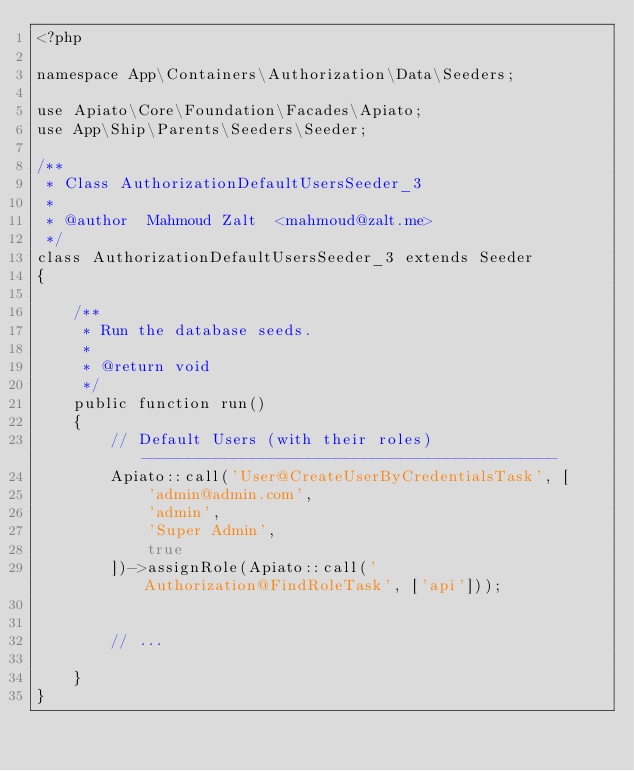Convert code to text. <code><loc_0><loc_0><loc_500><loc_500><_PHP_><?php

namespace App\Containers\Authorization\Data\Seeders;

use Apiato\Core\Foundation\Facades\Apiato;
use App\Ship\Parents\Seeders\Seeder;

/**
 * Class AuthorizationDefaultUsersSeeder_3
 *
 * @author  Mahmoud Zalt  <mahmoud@zalt.me>
 */
class AuthorizationDefaultUsersSeeder_3 extends Seeder
{

    /**
     * Run the database seeds.
     *
     * @return void
     */
    public function run()
    {
        // Default Users (with their roles) ---------------------------------------------
        Apiato::call('User@CreateUserByCredentialsTask', [
            'admin@admin.com',
            'admin',
            'Super Admin',
            true
        ])->assignRole(Apiato::call('Authorization@FindRoleTask', ['api']));
    

        // ...

    }
}
</code> 